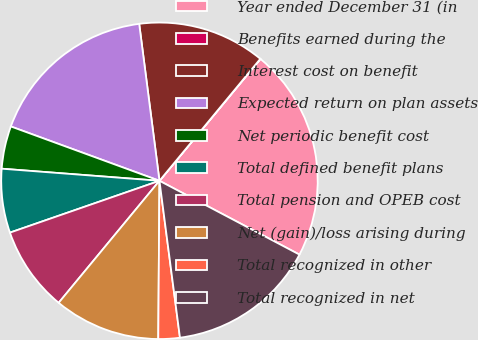Convert chart to OTSL. <chart><loc_0><loc_0><loc_500><loc_500><pie_chart><fcel>Year ended December 31 (in<fcel>Benefits earned during the<fcel>Interest cost on benefit<fcel>Expected return on plan assets<fcel>Net periodic benefit cost<fcel>Total defined benefit plans<fcel>Total pension and OPEB cost<fcel>Net (gain)/loss arising during<fcel>Total recognized in other<fcel>Total recognized in net<nl><fcel>21.71%<fcel>0.02%<fcel>13.04%<fcel>17.38%<fcel>4.36%<fcel>6.53%<fcel>8.7%<fcel>10.87%<fcel>2.19%<fcel>15.21%<nl></chart> 